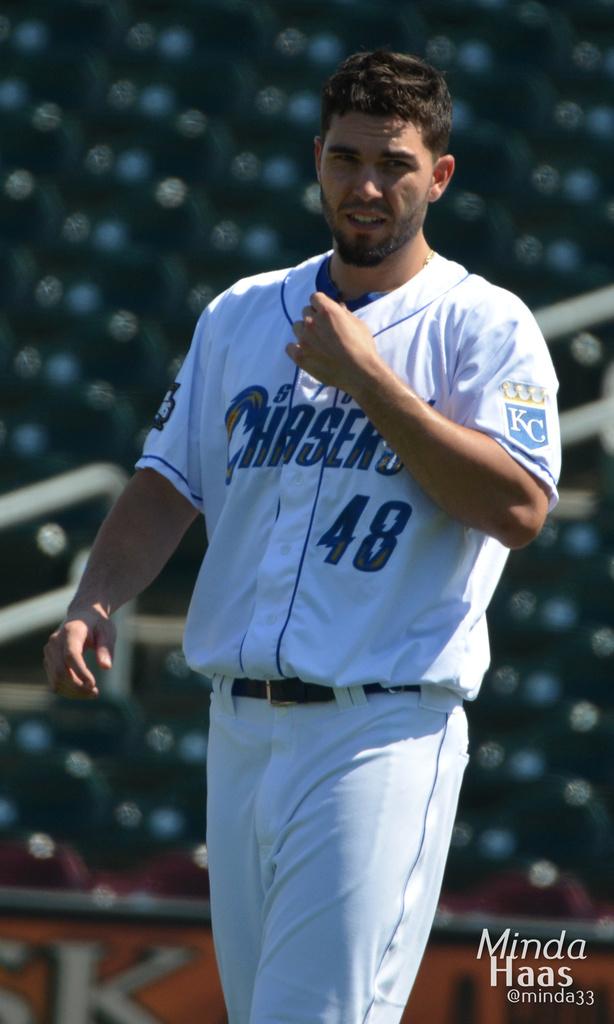What number jersey is this player wearing?
Provide a succinct answer. 48. What team does he play for?
Your answer should be compact. Chasers. 